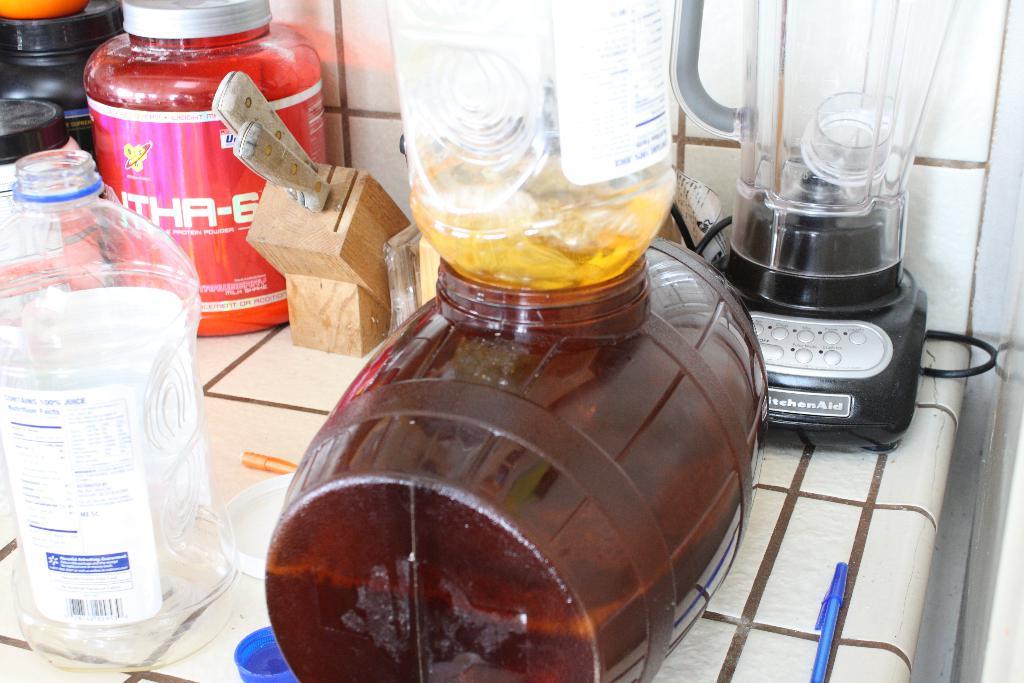What brand is the blender?
Provide a succinct answer. Kitchen aid. 